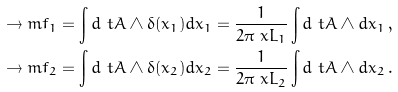<formula> <loc_0><loc_0><loc_500><loc_500>\to m f _ { 1 } & = \int d \ t A \wedge \delta ( x _ { 1 } ) d x _ { 1 } = \frac { 1 } { 2 \pi \ x L _ { 1 } } \int d \ t A \wedge d x _ { 1 } \, , \\ \to m f _ { 2 } & = \int d \ t A \wedge \delta ( x _ { 2 } ) d x _ { 2 } = \frac { 1 } { 2 \pi \ x L _ { 2 } } \int d \ t A \wedge d x _ { 2 } \, .</formula> 